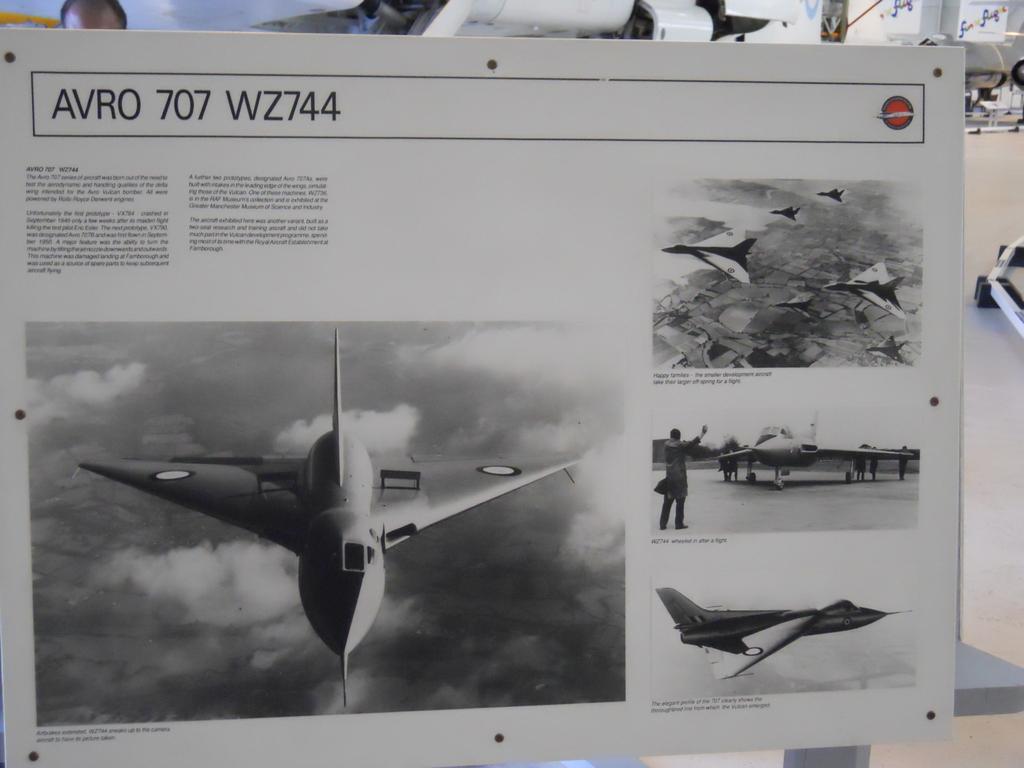Could you give a brief overview of what you see in this image? In this picture I can see a board with some pictures of fighter jets and text and I can see a human head and looks like couple of planes on the back and I can see a table. 